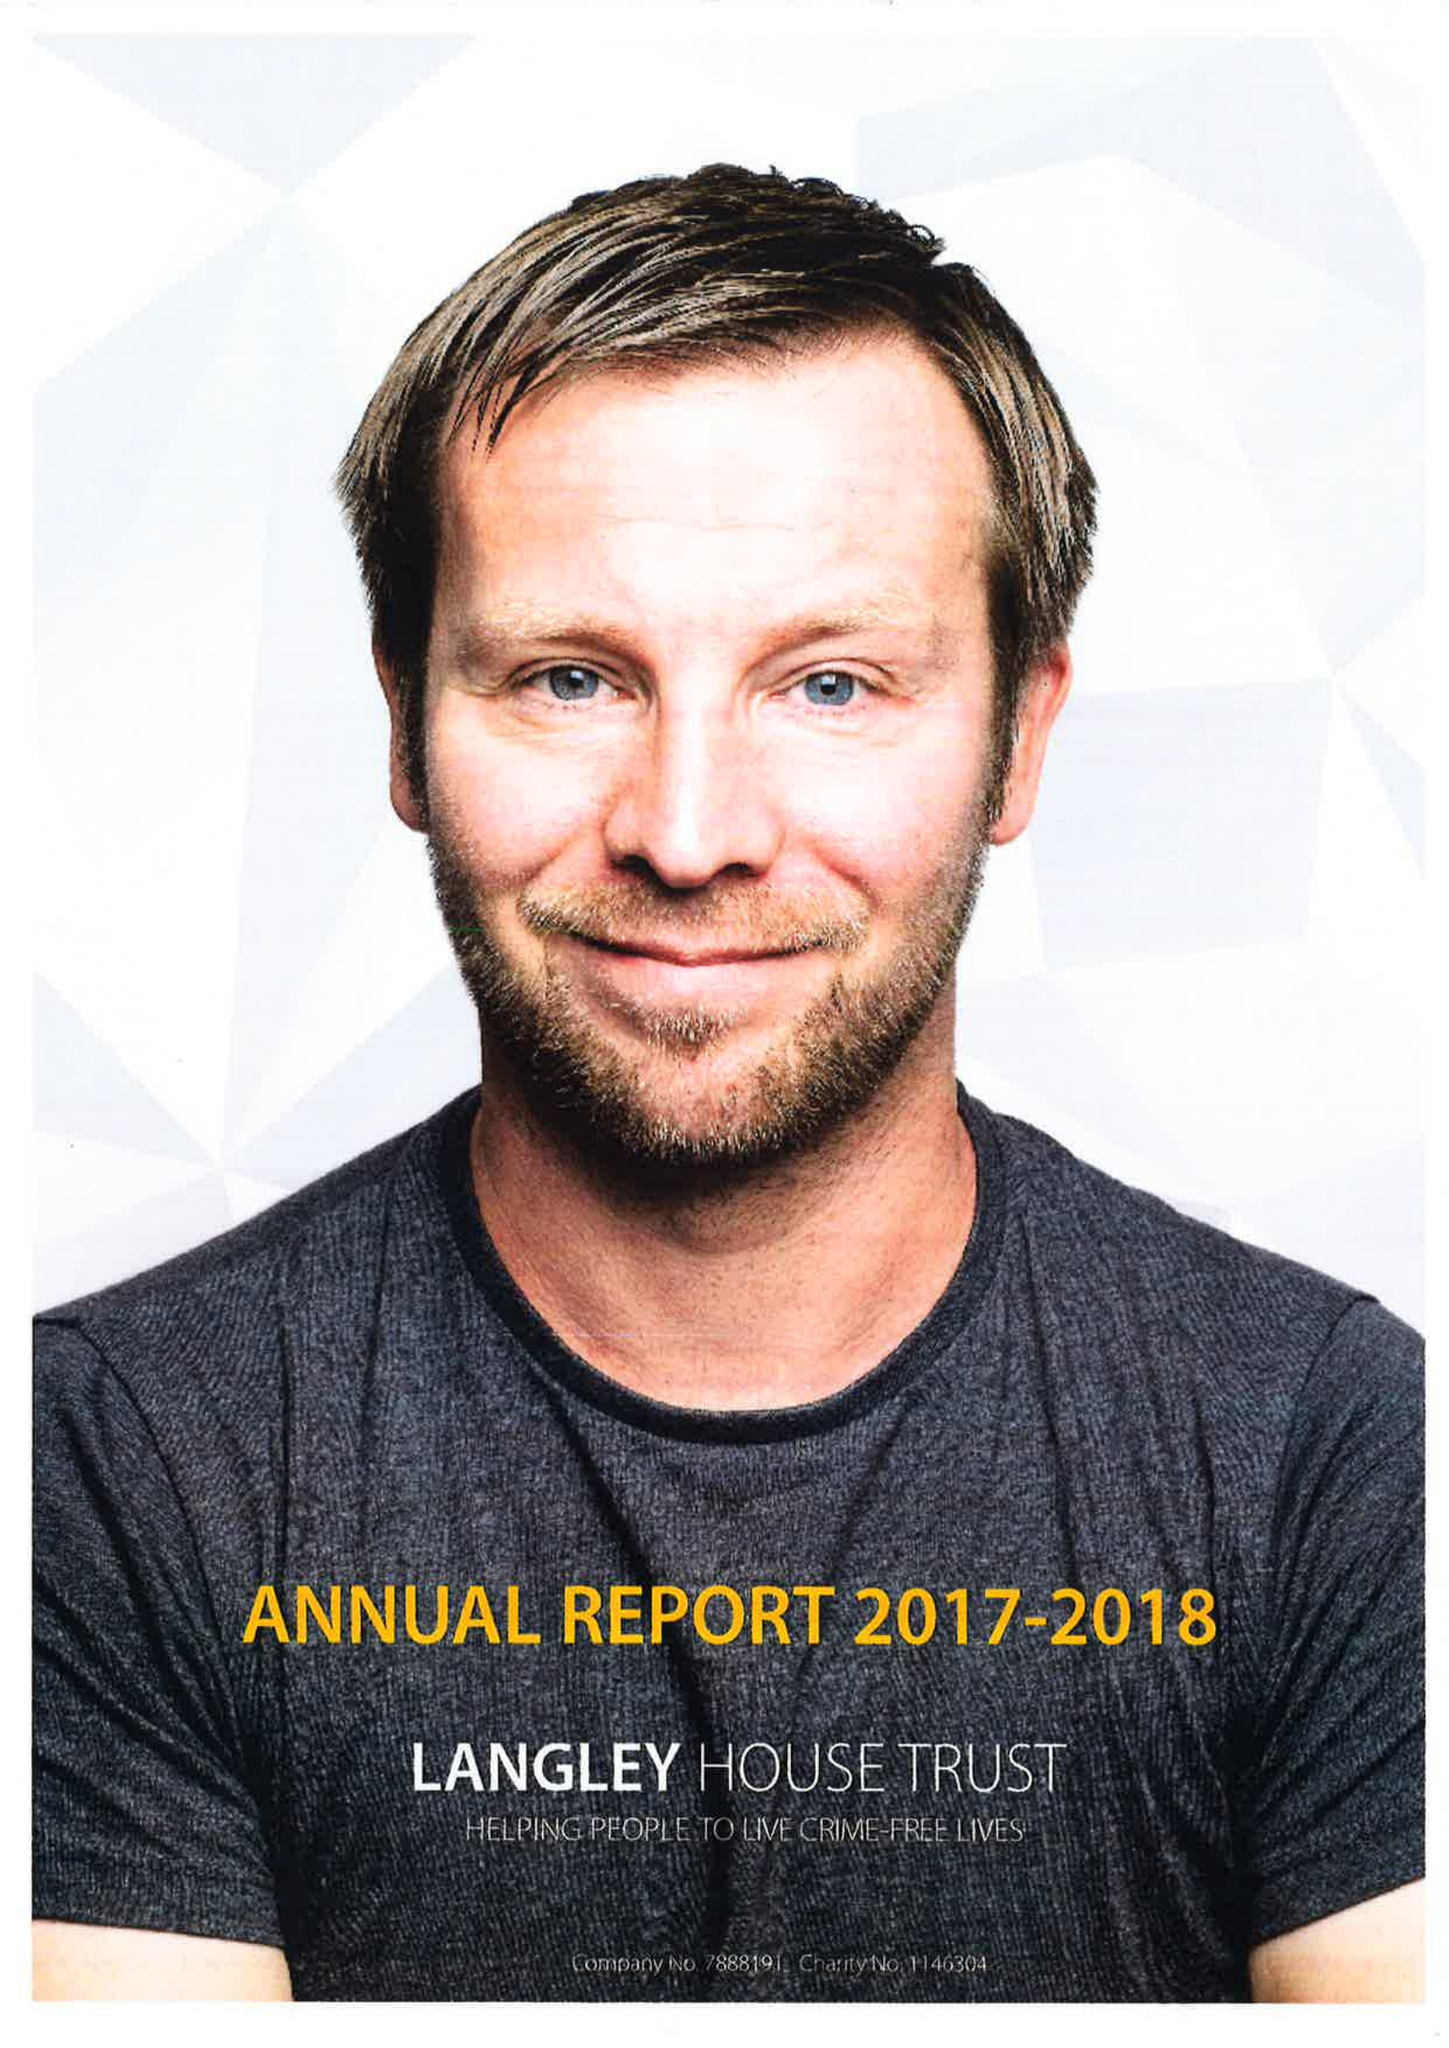What is the value for the report_date?
Answer the question using a single word or phrase. 2018-03-31 